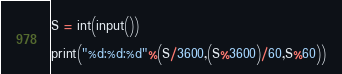<code> <loc_0><loc_0><loc_500><loc_500><_Python_>S = int(input())

print("%d:%d:%d"%(S/3600,(S%3600)/60,S%60))

</code> 